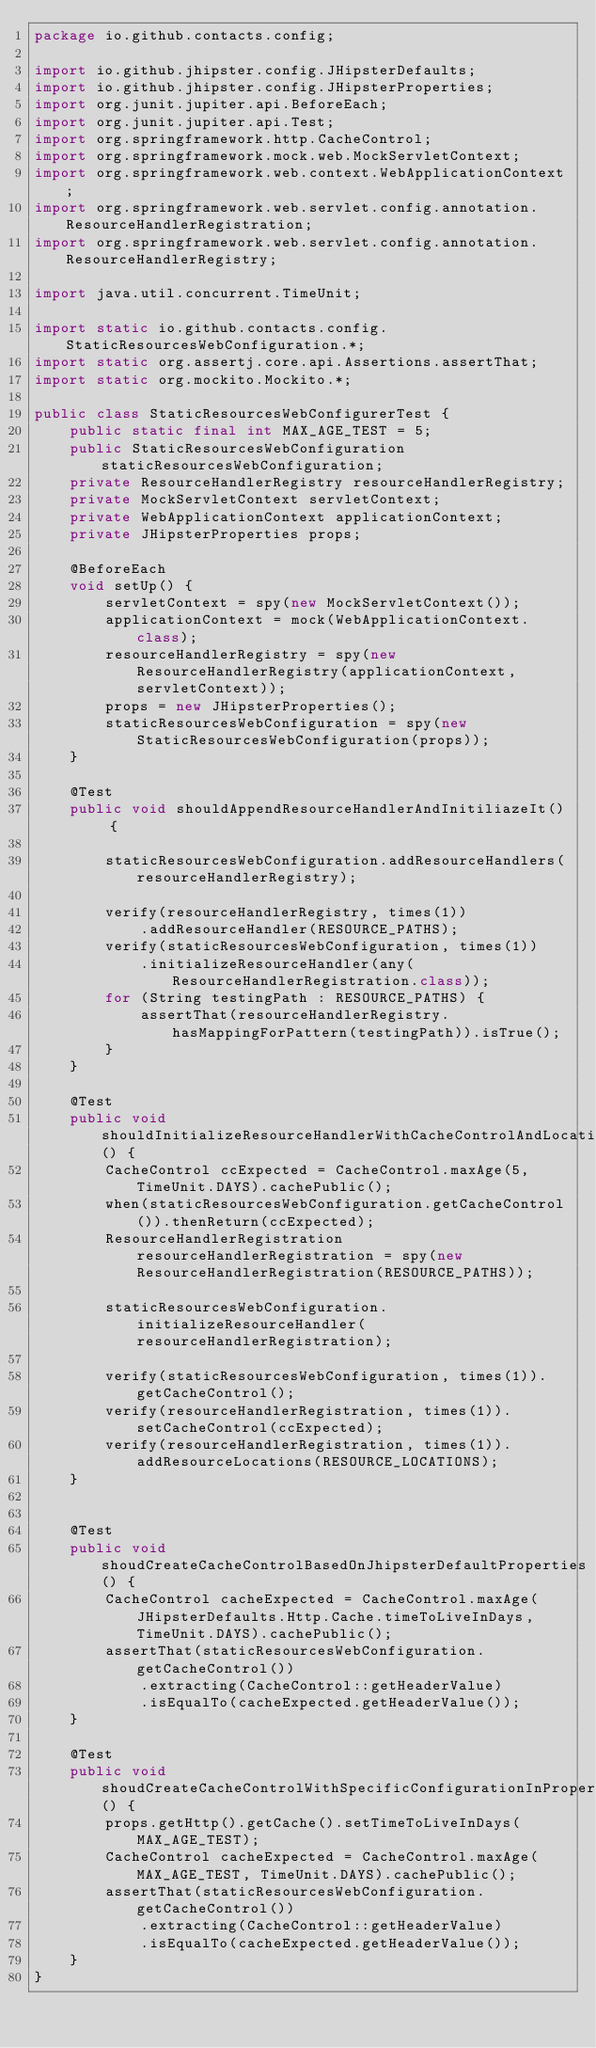<code> <loc_0><loc_0><loc_500><loc_500><_Java_>package io.github.contacts.config;

import io.github.jhipster.config.JHipsterDefaults;
import io.github.jhipster.config.JHipsterProperties;
import org.junit.jupiter.api.BeforeEach;
import org.junit.jupiter.api.Test;
import org.springframework.http.CacheControl;
import org.springframework.mock.web.MockServletContext;
import org.springframework.web.context.WebApplicationContext;
import org.springframework.web.servlet.config.annotation.ResourceHandlerRegistration;
import org.springframework.web.servlet.config.annotation.ResourceHandlerRegistry;

import java.util.concurrent.TimeUnit;

import static io.github.contacts.config.StaticResourcesWebConfiguration.*;
import static org.assertj.core.api.Assertions.assertThat;
import static org.mockito.Mockito.*;

public class StaticResourcesWebConfigurerTest {
    public static final int MAX_AGE_TEST = 5;
    public StaticResourcesWebConfiguration staticResourcesWebConfiguration;
    private ResourceHandlerRegistry resourceHandlerRegistry;
    private MockServletContext servletContext;
    private WebApplicationContext applicationContext;
    private JHipsterProperties props;

    @BeforeEach
    void setUp() {
        servletContext = spy(new MockServletContext());
        applicationContext = mock(WebApplicationContext.class);
        resourceHandlerRegistry = spy(new ResourceHandlerRegistry(applicationContext, servletContext));
        props = new JHipsterProperties();
        staticResourcesWebConfiguration = spy(new StaticResourcesWebConfiguration(props));
    }

    @Test
    public void shouldAppendResourceHandlerAndInitiliazeIt() {

        staticResourcesWebConfiguration.addResourceHandlers(resourceHandlerRegistry);

        verify(resourceHandlerRegistry, times(1))
            .addResourceHandler(RESOURCE_PATHS);
        verify(staticResourcesWebConfiguration, times(1))
            .initializeResourceHandler(any(ResourceHandlerRegistration.class));
        for (String testingPath : RESOURCE_PATHS) {
            assertThat(resourceHandlerRegistry.hasMappingForPattern(testingPath)).isTrue();
        }
    }

    @Test
    public void shouldInitializeResourceHandlerWithCacheControlAndLocations() {
        CacheControl ccExpected = CacheControl.maxAge(5, TimeUnit.DAYS).cachePublic();
        when(staticResourcesWebConfiguration.getCacheControl()).thenReturn(ccExpected);
        ResourceHandlerRegistration resourceHandlerRegistration = spy(new ResourceHandlerRegistration(RESOURCE_PATHS));

        staticResourcesWebConfiguration.initializeResourceHandler(resourceHandlerRegistration);

        verify(staticResourcesWebConfiguration, times(1)).getCacheControl();
        verify(resourceHandlerRegistration, times(1)).setCacheControl(ccExpected);
        verify(resourceHandlerRegistration, times(1)).addResourceLocations(RESOURCE_LOCATIONS);
    }


    @Test
    public void shoudCreateCacheControlBasedOnJhipsterDefaultProperties() {
        CacheControl cacheExpected = CacheControl.maxAge(JHipsterDefaults.Http.Cache.timeToLiveInDays, TimeUnit.DAYS).cachePublic();
        assertThat(staticResourcesWebConfiguration.getCacheControl())
            .extracting(CacheControl::getHeaderValue)
            .isEqualTo(cacheExpected.getHeaderValue());
    }

    @Test
    public void shoudCreateCacheControlWithSpecificConfigurationInProperties() {
        props.getHttp().getCache().setTimeToLiveInDays(MAX_AGE_TEST);
        CacheControl cacheExpected = CacheControl.maxAge(MAX_AGE_TEST, TimeUnit.DAYS).cachePublic();
        assertThat(staticResourcesWebConfiguration.getCacheControl())
            .extracting(CacheControl::getHeaderValue)
            .isEqualTo(cacheExpected.getHeaderValue());
    }
}
</code> 